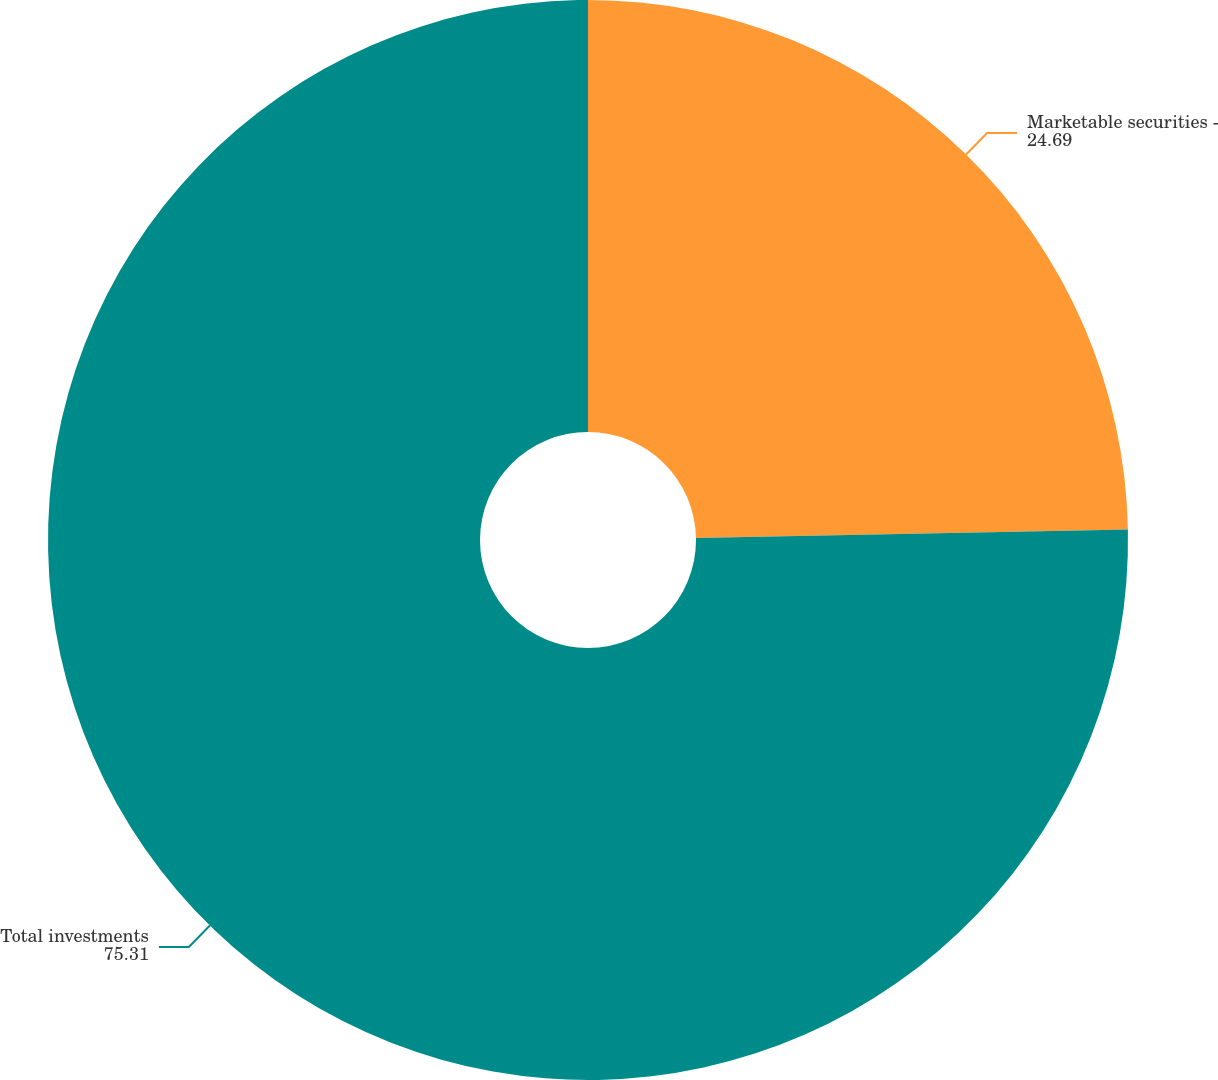<chart> <loc_0><loc_0><loc_500><loc_500><pie_chart><fcel>Marketable securities -<fcel>Total investments<nl><fcel>24.69%<fcel>75.31%<nl></chart> 